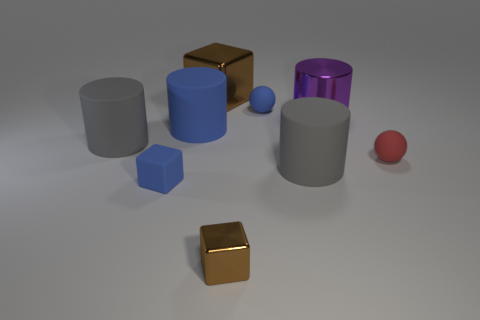Subtract all gray spheres. How many gray cylinders are left? 2 Subtract all large blue cylinders. How many cylinders are left? 3 Subtract all blue cylinders. How many cylinders are left? 3 Subtract 2 cylinders. How many cylinders are left? 2 Subtract all cubes. How many objects are left? 6 Subtract all cyan blocks. Subtract all cyan balls. How many blocks are left? 3 Subtract all tiny brown metallic cubes. Subtract all small blue blocks. How many objects are left? 7 Add 5 tiny blue rubber objects. How many tiny blue rubber objects are left? 7 Add 9 big brown cubes. How many big brown cubes exist? 10 Subtract 2 gray cylinders. How many objects are left? 7 